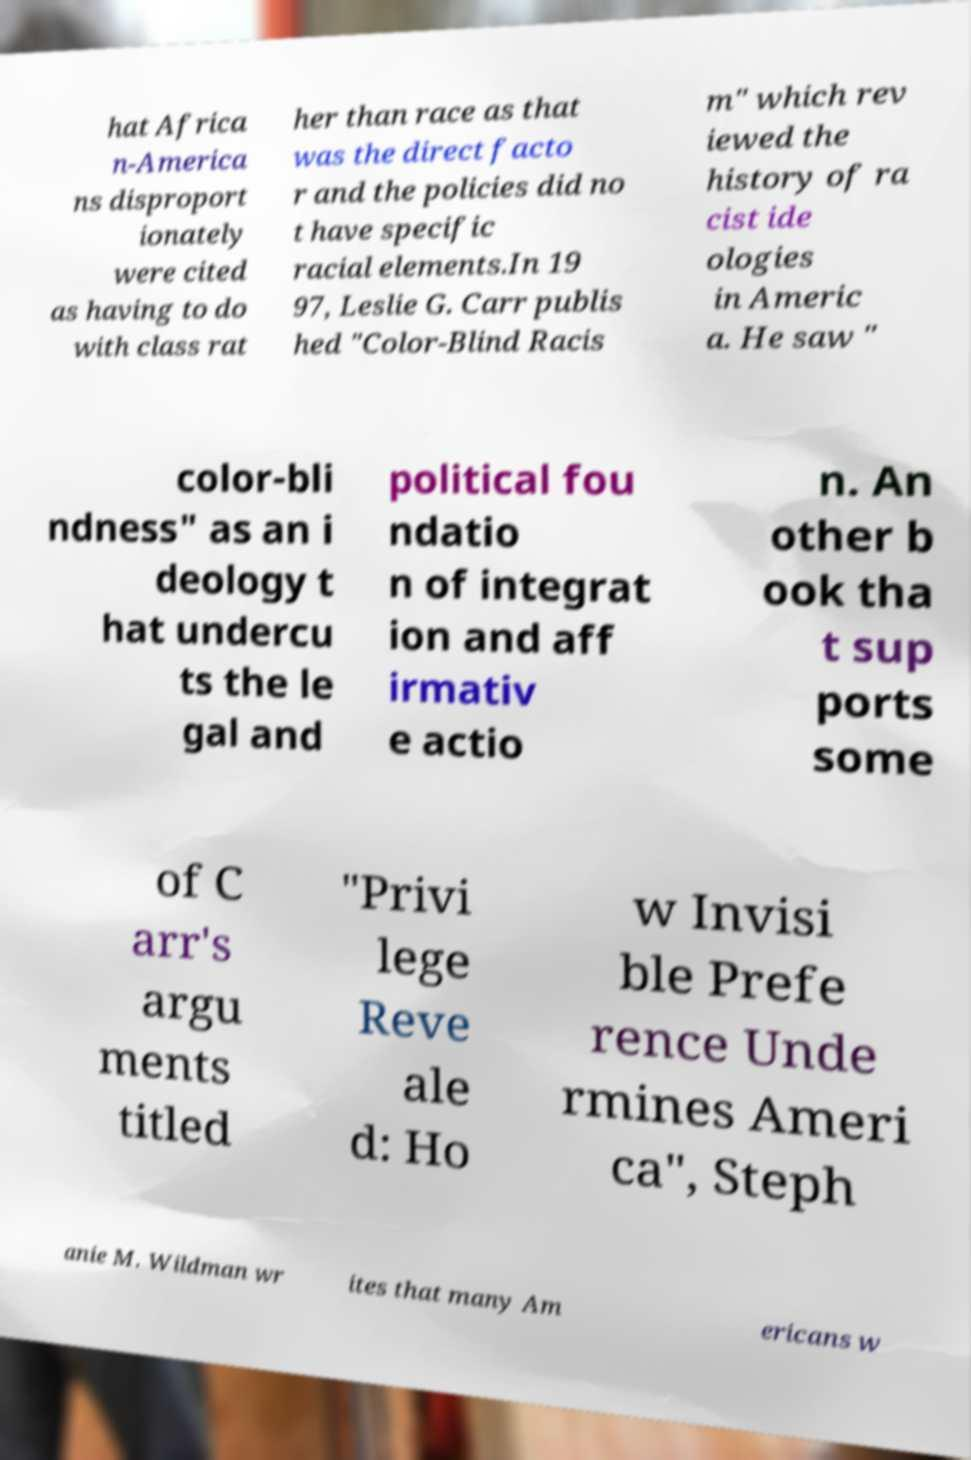Could you extract and type out the text from this image? hat Africa n-America ns disproport ionately were cited as having to do with class rat her than race as that was the direct facto r and the policies did no t have specific racial elements.In 19 97, Leslie G. Carr publis hed "Color-Blind Racis m" which rev iewed the history of ra cist ide ologies in Americ a. He saw " color-bli ndness" as an i deology t hat undercu ts the le gal and political fou ndatio n of integrat ion and aff irmativ e actio n. An other b ook tha t sup ports some of C arr's argu ments titled "Privi lege Reve ale d: Ho w Invisi ble Prefe rence Unde rmines Ameri ca", Steph anie M. Wildman wr ites that many Am ericans w 